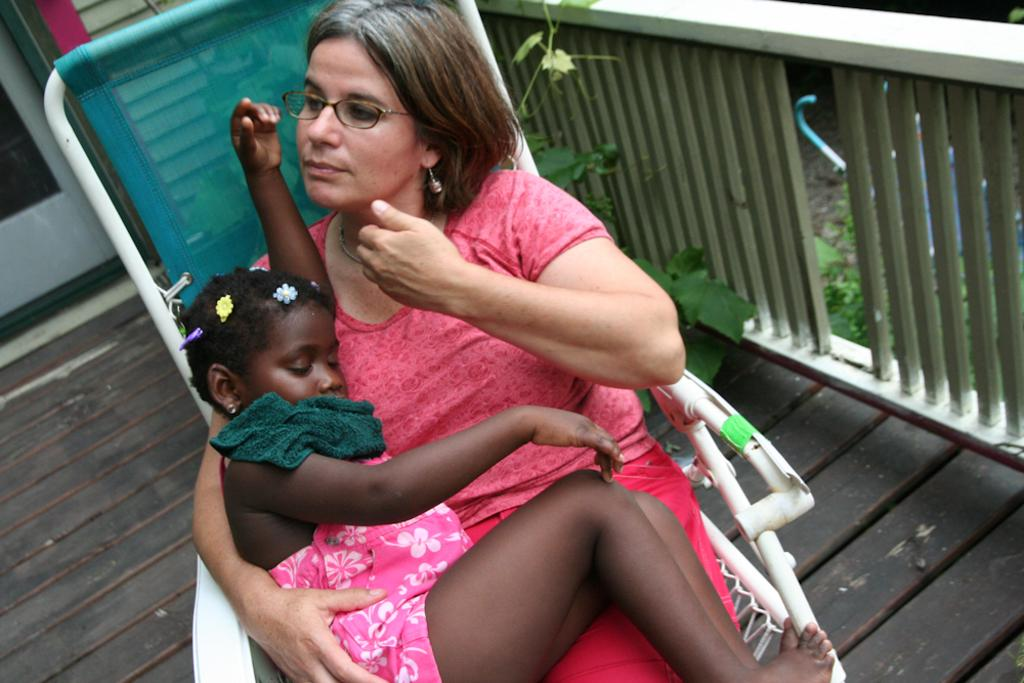Who is the main subject in the image? There is a woman in the image. What is the woman doing in the image? The woman is sitting in a chair and holding a girl child. What is located beside the chair? There is railing beside the chair. What can be seen behind the chair? There is a part of a door visible behind the chair. What is the reason for the woman's wrist being visible in the image? The woman's wrist is not visible in the image, so there is no reason to discuss it. 